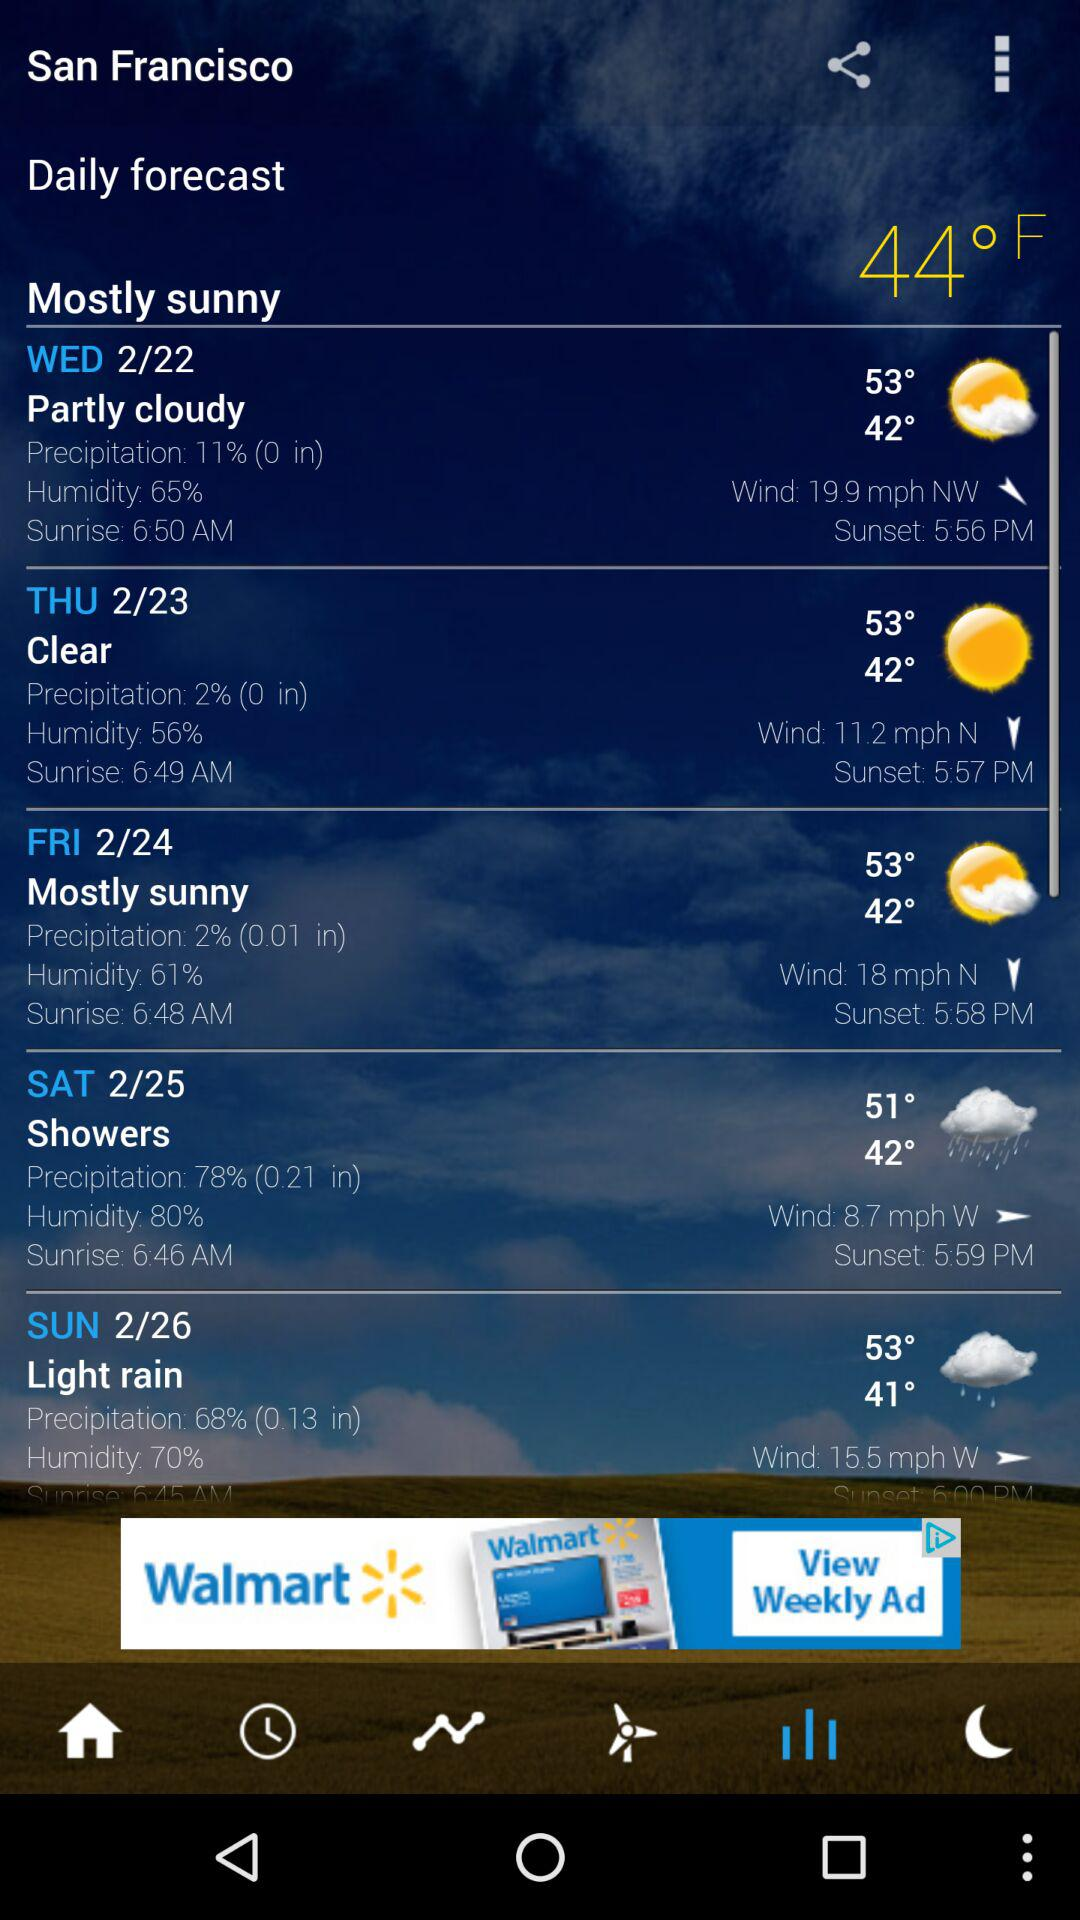What is the percentage of humidity on Saturday in San Francisco? The percentage of humidity is 80. 